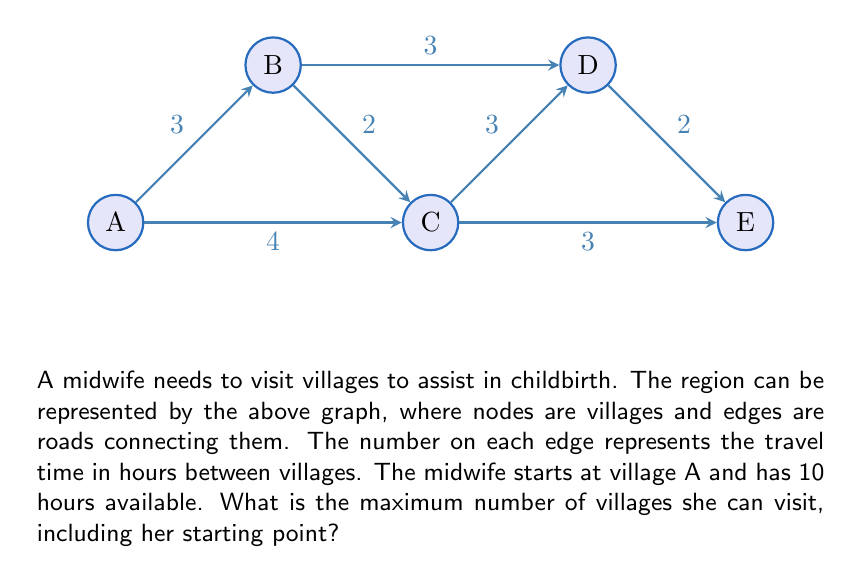Provide a solution to this math problem. To solve this problem, we need to find the path that allows the midwife to visit the maximum number of villages within the 10-hour time frame. Let's approach this step-by-step:

1) First, we need to consider all possible paths starting from village A.

2) The shortest path to visit all villages is A-C-E-D-B, but this takes 12 hours (4+3+2+3), which exceeds our time limit.

3) Let's consider shorter paths:

   A-C-E: 7 hours (4+3)
   A-C-D: 7 hours (4+3)
   A-B-D: 6 hours (3+3)
   A-C-B: 6 hours (4+2)

4) Among these, A-C-E and A-C-D allow visiting 3 villages in 7 hours, leaving 3 hours unused.

5) We can extend A-C-D to A-C-D-E, which takes 9 hours (4+3+2) and visits 4 villages.

6) No other combination allows visiting more villages within the 10-hour limit.

Therefore, the maximum number of villages the midwife can visit, including her starting point, is 4.
Answer: 4 villages 